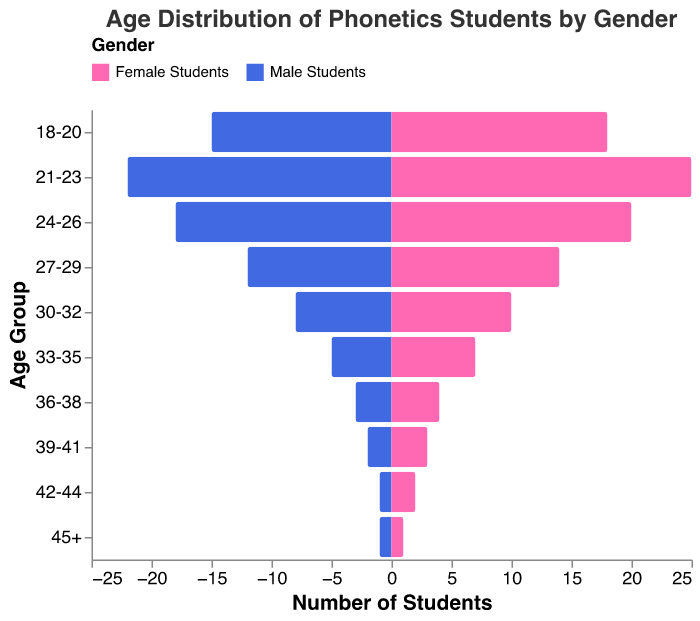What is the title of the figure? The title of the figure is displayed at the top and is written as "Age Distribution of Phonetics Students by Gender".
Answer: Age Distribution of Phonetics Students by Gender Which age group has the highest number of female students? By looking at the length of the bars for female students (represented in pink), the age group 21-23 has the longest bar, indicating the highest number of female students.
Answer: 21-23 How many male students are there in the 24-26 age group? Locate the bar for male students in the 24-26 age group, which extends to the value 18 on the negative side of the x-axis.
Answer: 18 What is the total number of students aged 18-20? Sum the values for male and female students in the 18-20 age group, which are 15 and 18, respectively. So, 15 + 18 = 33.
Answer: 33 Which gender has more students aged 33-35? Compare the lengths of the bars for male and female students in the 33-35 age group. The bar for female students extends further, indicating more female students.
Answer: Female What is the difference between the number of male and female students aged 30-32? Subtract the number of male students (8) from the number of female students (10) in the 30-32 age group. So, 10 - 8 = 2.
Answer: 2 How many students aged 36-38 are enrolled in total? Add the values for male and female students in the 36-38 age group, which are 3 and 4, respectively. So, 3 + 4 = 7.
Answer: 7 Compare the number of students in age groups 27-29 and 39-41. Which group has more students? Sum the values for male and female students in each age group. For 27-29: 12 (male) + 14 (female) = 26. For 39-41: 2 (male) + 3 (female) = 5. The 27-29 group has more students.
Answer: 27-29 Which age group shows an equal number of male and female students? Look for bars where the values for male and female students are equal. The age group 45+ has 1 male and 1 female student, making them equal.
Answer: 45+ 